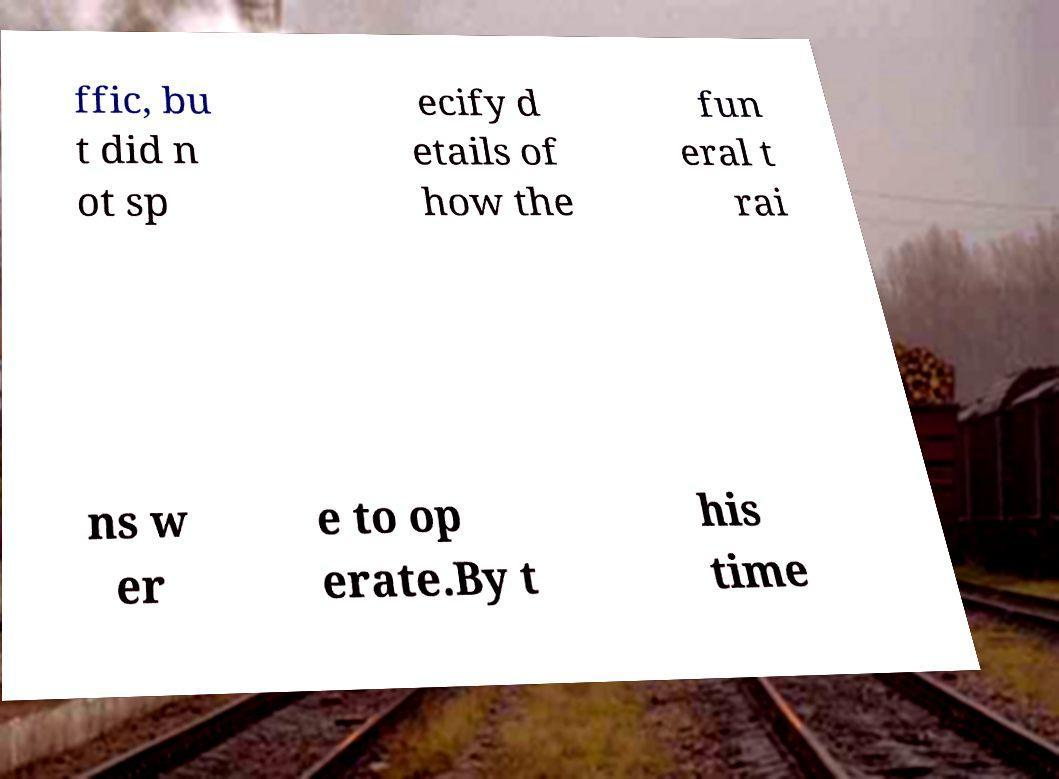I need the written content from this picture converted into text. Can you do that? ffic, bu t did n ot sp ecify d etails of how the fun eral t rai ns w er e to op erate.By t his time 